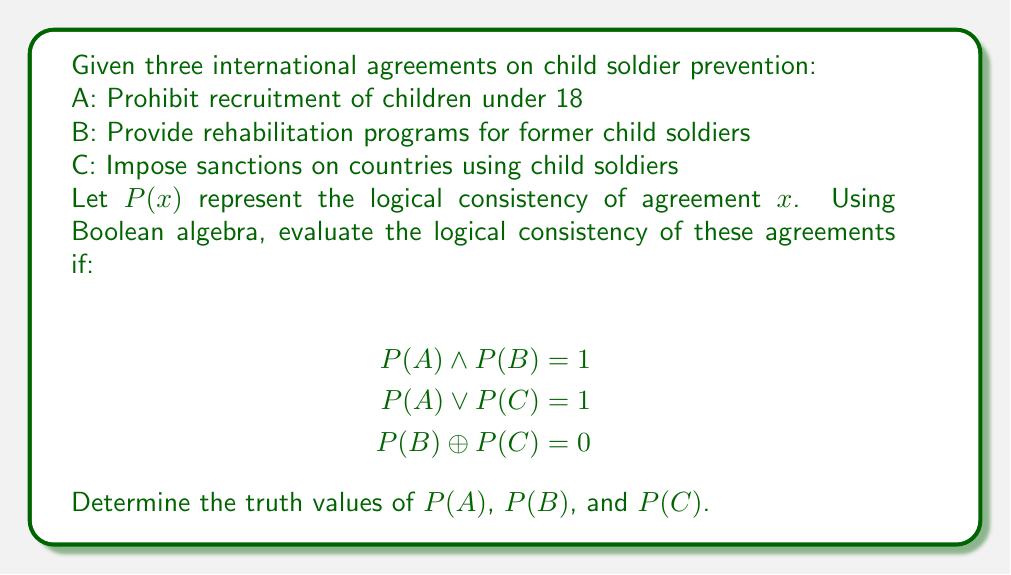Can you solve this math problem? Let's approach this step-by-step:

1) From $P(A) \land P(B) = 1$, we can conclude that both $P(A)$ and $P(B)$ must be true (1), because the AND operation only results in 1 if both inputs are 1.

2) $P(A) \lor P(C) = 1$ is already satisfied by $P(A) = 1$, so this doesn't give us any information about $P(C)$.

3) $P(B) \oplus P(C) = 0$ means that $P(B)$ and $P(C)$ must have the same truth value, because XOR is 0 when both inputs are the same.

4) We know $P(B) = 1$ from step 1, so $P(C)$ must also be 1 to satisfy the XOR condition.

Therefore:
$P(A) = 1$
$P(B) = 1$
$P(C) = 1$

We can verify:
$P(A) \land P(B) = 1 \land 1 = 1$ ✓
$P(A) \lor P(C) = 1 \lor 1 = 1$ ✓
$P(B) \oplus P(C) = 1 \oplus 1 = 0$ ✓

All conditions are satisfied, confirming the logical consistency of all three agreements.
Answer: $P(A) = 1$, $P(B) = 1$, $P(C) = 1$ 